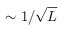Convert formula to latex. <formula><loc_0><loc_0><loc_500><loc_500>\sim 1 / \sqrt { L }</formula> 